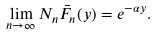<formula> <loc_0><loc_0><loc_500><loc_500>\lim _ { n \to \infty } N _ { n } \bar { F } _ { n } ( y ) = e ^ { - \alpha y } .</formula> 